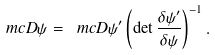<formula> <loc_0><loc_0><loc_500><loc_500>\ m c D \psi = \ m c D \psi ^ { \prime } \left ( \det \frac { \delta \psi ^ { \prime } } { \delta \psi } \right ) ^ { - 1 } .</formula> 